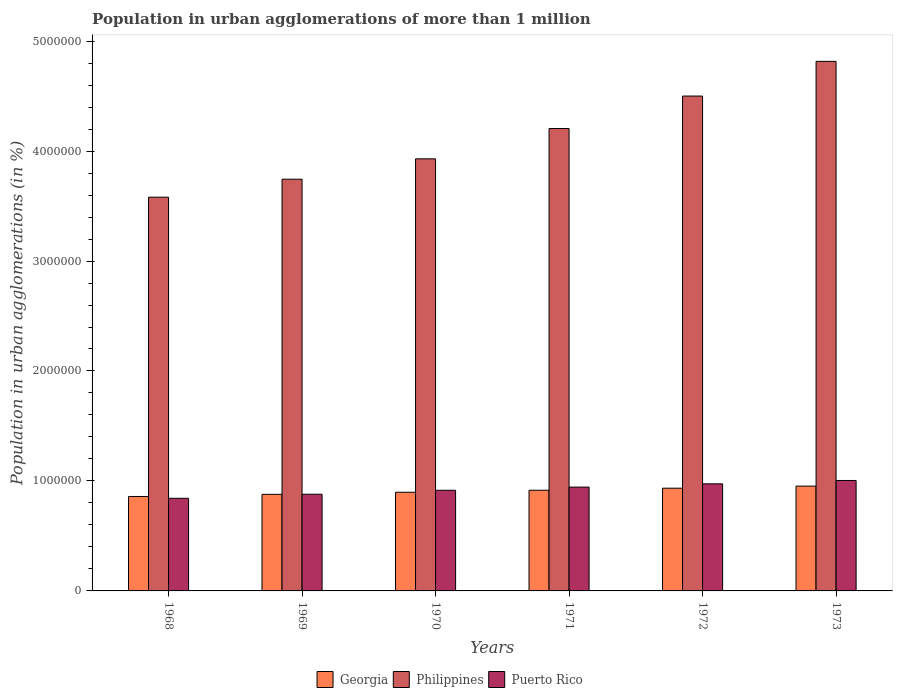How many different coloured bars are there?
Keep it short and to the point. 3. Are the number of bars per tick equal to the number of legend labels?
Give a very brief answer. Yes. How many bars are there on the 1st tick from the right?
Your answer should be compact. 3. What is the label of the 6th group of bars from the left?
Offer a very short reply. 1973. What is the population in urban agglomerations in Philippines in 1972?
Offer a terse response. 4.50e+06. Across all years, what is the maximum population in urban agglomerations in Philippines?
Make the answer very short. 4.82e+06. Across all years, what is the minimum population in urban agglomerations in Georgia?
Offer a very short reply. 8.59e+05. In which year was the population in urban agglomerations in Philippines maximum?
Offer a very short reply. 1973. In which year was the population in urban agglomerations in Georgia minimum?
Make the answer very short. 1968. What is the total population in urban agglomerations in Philippines in the graph?
Your response must be concise. 2.48e+07. What is the difference between the population in urban agglomerations in Puerto Rico in 1970 and that in 1971?
Your response must be concise. -2.88e+04. What is the difference between the population in urban agglomerations in Philippines in 1969 and the population in urban agglomerations in Puerto Rico in 1971?
Your answer should be compact. 2.80e+06. What is the average population in urban agglomerations in Puerto Rico per year?
Offer a very short reply. 9.27e+05. In the year 1969, what is the difference between the population in urban agglomerations in Georgia and population in urban agglomerations in Philippines?
Keep it short and to the point. -2.87e+06. In how many years, is the population in urban agglomerations in Philippines greater than 3200000 %?
Your answer should be compact. 6. What is the ratio of the population in urban agglomerations in Puerto Rico in 1970 to that in 1972?
Provide a succinct answer. 0.94. What is the difference between the highest and the second highest population in urban agglomerations in Georgia?
Provide a succinct answer. 1.90e+04. What is the difference between the highest and the lowest population in urban agglomerations in Georgia?
Provide a short and direct response. 9.44e+04. In how many years, is the population in urban agglomerations in Georgia greater than the average population in urban agglomerations in Georgia taken over all years?
Your response must be concise. 3. What does the 3rd bar from the right in 1973 represents?
Make the answer very short. Georgia. How many bars are there?
Make the answer very short. 18. How many years are there in the graph?
Offer a terse response. 6. Are the values on the major ticks of Y-axis written in scientific E-notation?
Your answer should be very brief. No. Does the graph contain any zero values?
Your answer should be compact. No. Does the graph contain grids?
Your answer should be compact. No. What is the title of the graph?
Your answer should be compact. Population in urban agglomerations of more than 1 million. Does "New Caledonia" appear as one of the legend labels in the graph?
Your response must be concise. No. What is the label or title of the X-axis?
Offer a very short reply. Years. What is the label or title of the Y-axis?
Provide a succinct answer. Population in urban agglomerations (in %). What is the Population in urban agglomerations (in %) of Georgia in 1968?
Your answer should be compact. 8.59e+05. What is the Population in urban agglomerations (in %) of Philippines in 1968?
Keep it short and to the point. 3.58e+06. What is the Population in urban agglomerations (in %) in Puerto Rico in 1968?
Keep it short and to the point. 8.42e+05. What is the Population in urban agglomerations (in %) in Georgia in 1969?
Offer a terse response. 8.78e+05. What is the Population in urban agglomerations (in %) of Philippines in 1969?
Provide a short and direct response. 3.74e+06. What is the Population in urban agglomerations (in %) in Puerto Rico in 1969?
Ensure brevity in your answer.  8.79e+05. What is the Population in urban agglomerations (in %) of Georgia in 1970?
Offer a very short reply. 8.97e+05. What is the Population in urban agglomerations (in %) in Philippines in 1970?
Ensure brevity in your answer.  3.93e+06. What is the Population in urban agglomerations (in %) of Puerto Rico in 1970?
Ensure brevity in your answer.  9.15e+05. What is the Population in urban agglomerations (in %) of Georgia in 1971?
Give a very brief answer. 9.16e+05. What is the Population in urban agglomerations (in %) of Philippines in 1971?
Give a very brief answer. 4.20e+06. What is the Population in urban agglomerations (in %) in Puerto Rico in 1971?
Your answer should be very brief. 9.44e+05. What is the Population in urban agglomerations (in %) of Georgia in 1972?
Your answer should be compact. 9.34e+05. What is the Population in urban agglomerations (in %) of Philippines in 1972?
Your answer should be compact. 4.50e+06. What is the Population in urban agglomerations (in %) of Puerto Rico in 1972?
Your answer should be very brief. 9.74e+05. What is the Population in urban agglomerations (in %) of Georgia in 1973?
Offer a terse response. 9.53e+05. What is the Population in urban agglomerations (in %) of Philippines in 1973?
Ensure brevity in your answer.  4.82e+06. What is the Population in urban agglomerations (in %) in Puerto Rico in 1973?
Provide a short and direct response. 1.00e+06. Across all years, what is the maximum Population in urban agglomerations (in %) of Georgia?
Ensure brevity in your answer.  9.53e+05. Across all years, what is the maximum Population in urban agglomerations (in %) in Philippines?
Your answer should be compact. 4.82e+06. Across all years, what is the maximum Population in urban agglomerations (in %) of Puerto Rico?
Provide a succinct answer. 1.00e+06. Across all years, what is the minimum Population in urban agglomerations (in %) in Georgia?
Offer a terse response. 8.59e+05. Across all years, what is the minimum Population in urban agglomerations (in %) of Philippines?
Offer a terse response. 3.58e+06. Across all years, what is the minimum Population in urban agglomerations (in %) in Puerto Rico?
Provide a succinct answer. 8.42e+05. What is the total Population in urban agglomerations (in %) of Georgia in the graph?
Offer a very short reply. 5.44e+06. What is the total Population in urban agglomerations (in %) in Philippines in the graph?
Make the answer very short. 2.48e+07. What is the total Population in urban agglomerations (in %) in Puerto Rico in the graph?
Your answer should be compact. 5.56e+06. What is the difference between the Population in urban agglomerations (in %) in Georgia in 1968 and that in 1969?
Make the answer very short. -1.94e+04. What is the difference between the Population in urban agglomerations (in %) of Philippines in 1968 and that in 1969?
Your answer should be very brief. -1.64e+05. What is the difference between the Population in urban agglomerations (in %) of Puerto Rico in 1968 and that in 1969?
Provide a succinct answer. -3.71e+04. What is the difference between the Population in urban agglomerations (in %) of Georgia in 1968 and that in 1970?
Your answer should be very brief. -3.84e+04. What is the difference between the Population in urban agglomerations (in %) of Philippines in 1968 and that in 1970?
Provide a short and direct response. -3.49e+05. What is the difference between the Population in urban agglomerations (in %) of Puerto Rico in 1968 and that in 1970?
Keep it short and to the point. -7.31e+04. What is the difference between the Population in urban agglomerations (in %) in Georgia in 1968 and that in 1971?
Offer a terse response. -5.67e+04. What is the difference between the Population in urban agglomerations (in %) of Philippines in 1968 and that in 1971?
Your answer should be very brief. -6.24e+05. What is the difference between the Population in urban agglomerations (in %) in Puerto Rico in 1968 and that in 1971?
Your answer should be very brief. -1.02e+05. What is the difference between the Population in urban agglomerations (in %) of Georgia in 1968 and that in 1972?
Provide a succinct answer. -7.54e+04. What is the difference between the Population in urban agglomerations (in %) in Philippines in 1968 and that in 1972?
Your response must be concise. -9.20e+05. What is the difference between the Population in urban agglomerations (in %) of Puerto Rico in 1968 and that in 1972?
Provide a short and direct response. -1.32e+05. What is the difference between the Population in urban agglomerations (in %) in Georgia in 1968 and that in 1973?
Provide a short and direct response. -9.44e+04. What is the difference between the Population in urban agglomerations (in %) in Philippines in 1968 and that in 1973?
Give a very brief answer. -1.24e+06. What is the difference between the Population in urban agglomerations (in %) in Puerto Rico in 1968 and that in 1973?
Your response must be concise. -1.62e+05. What is the difference between the Population in urban agglomerations (in %) in Georgia in 1969 and that in 1970?
Offer a very short reply. -1.90e+04. What is the difference between the Population in urban agglomerations (in %) of Philippines in 1969 and that in 1970?
Make the answer very short. -1.85e+05. What is the difference between the Population in urban agglomerations (in %) in Puerto Rico in 1969 and that in 1970?
Provide a succinct answer. -3.60e+04. What is the difference between the Population in urban agglomerations (in %) of Georgia in 1969 and that in 1971?
Your response must be concise. -3.73e+04. What is the difference between the Population in urban agglomerations (in %) of Philippines in 1969 and that in 1971?
Provide a short and direct response. -4.61e+05. What is the difference between the Population in urban agglomerations (in %) of Puerto Rico in 1969 and that in 1971?
Offer a very short reply. -6.48e+04. What is the difference between the Population in urban agglomerations (in %) in Georgia in 1969 and that in 1972?
Give a very brief answer. -5.60e+04. What is the difference between the Population in urban agglomerations (in %) in Philippines in 1969 and that in 1972?
Keep it short and to the point. -7.56e+05. What is the difference between the Population in urban agglomerations (in %) in Puerto Rico in 1969 and that in 1972?
Keep it short and to the point. -9.45e+04. What is the difference between the Population in urban agglomerations (in %) in Georgia in 1969 and that in 1973?
Give a very brief answer. -7.50e+04. What is the difference between the Population in urban agglomerations (in %) of Philippines in 1969 and that in 1973?
Keep it short and to the point. -1.07e+06. What is the difference between the Population in urban agglomerations (in %) of Puerto Rico in 1969 and that in 1973?
Provide a short and direct response. -1.25e+05. What is the difference between the Population in urban agglomerations (in %) of Georgia in 1970 and that in 1971?
Provide a succinct answer. -1.83e+04. What is the difference between the Population in urban agglomerations (in %) in Philippines in 1970 and that in 1971?
Your answer should be compact. -2.75e+05. What is the difference between the Population in urban agglomerations (in %) in Puerto Rico in 1970 and that in 1971?
Provide a short and direct response. -2.88e+04. What is the difference between the Population in urban agglomerations (in %) in Georgia in 1970 and that in 1972?
Keep it short and to the point. -3.70e+04. What is the difference between the Population in urban agglomerations (in %) in Philippines in 1970 and that in 1972?
Make the answer very short. -5.71e+05. What is the difference between the Population in urban agglomerations (in %) in Puerto Rico in 1970 and that in 1972?
Your answer should be compact. -5.85e+04. What is the difference between the Population in urban agglomerations (in %) of Georgia in 1970 and that in 1973?
Ensure brevity in your answer.  -5.60e+04. What is the difference between the Population in urban agglomerations (in %) of Philippines in 1970 and that in 1973?
Give a very brief answer. -8.86e+05. What is the difference between the Population in urban agglomerations (in %) in Puerto Rico in 1970 and that in 1973?
Keep it short and to the point. -8.91e+04. What is the difference between the Population in urban agglomerations (in %) of Georgia in 1971 and that in 1972?
Give a very brief answer. -1.87e+04. What is the difference between the Population in urban agglomerations (in %) in Philippines in 1971 and that in 1972?
Offer a very short reply. -2.95e+05. What is the difference between the Population in urban agglomerations (in %) of Puerto Rico in 1971 and that in 1972?
Offer a very short reply. -2.97e+04. What is the difference between the Population in urban agglomerations (in %) of Georgia in 1971 and that in 1973?
Provide a succinct answer. -3.77e+04. What is the difference between the Population in urban agglomerations (in %) in Philippines in 1971 and that in 1973?
Offer a very short reply. -6.11e+05. What is the difference between the Population in urban agglomerations (in %) of Puerto Rico in 1971 and that in 1973?
Provide a succinct answer. -6.03e+04. What is the difference between the Population in urban agglomerations (in %) in Georgia in 1972 and that in 1973?
Your answer should be very brief. -1.90e+04. What is the difference between the Population in urban agglomerations (in %) in Philippines in 1972 and that in 1973?
Give a very brief answer. -3.16e+05. What is the difference between the Population in urban agglomerations (in %) in Puerto Rico in 1972 and that in 1973?
Provide a succinct answer. -3.06e+04. What is the difference between the Population in urban agglomerations (in %) in Georgia in 1968 and the Population in urban agglomerations (in %) in Philippines in 1969?
Make the answer very short. -2.89e+06. What is the difference between the Population in urban agglomerations (in %) in Georgia in 1968 and the Population in urban agglomerations (in %) in Puerto Rico in 1969?
Offer a terse response. -2.05e+04. What is the difference between the Population in urban agglomerations (in %) in Philippines in 1968 and the Population in urban agglomerations (in %) in Puerto Rico in 1969?
Ensure brevity in your answer.  2.70e+06. What is the difference between the Population in urban agglomerations (in %) in Georgia in 1968 and the Population in urban agglomerations (in %) in Philippines in 1970?
Provide a succinct answer. -3.07e+06. What is the difference between the Population in urban agglomerations (in %) of Georgia in 1968 and the Population in urban agglomerations (in %) of Puerto Rico in 1970?
Offer a terse response. -5.65e+04. What is the difference between the Population in urban agglomerations (in %) in Philippines in 1968 and the Population in urban agglomerations (in %) in Puerto Rico in 1970?
Your answer should be compact. 2.67e+06. What is the difference between the Population in urban agglomerations (in %) of Georgia in 1968 and the Population in urban agglomerations (in %) of Philippines in 1971?
Give a very brief answer. -3.35e+06. What is the difference between the Population in urban agglomerations (in %) of Georgia in 1968 and the Population in urban agglomerations (in %) of Puerto Rico in 1971?
Offer a very short reply. -8.53e+04. What is the difference between the Population in urban agglomerations (in %) in Philippines in 1968 and the Population in urban agglomerations (in %) in Puerto Rico in 1971?
Your answer should be very brief. 2.64e+06. What is the difference between the Population in urban agglomerations (in %) in Georgia in 1968 and the Population in urban agglomerations (in %) in Philippines in 1972?
Offer a very short reply. -3.64e+06. What is the difference between the Population in urban agglomerations (in %) in Georgia in 1968 and the Population in urban agglomerations (in %) in Puerto Rico in 1972?
Your response must be concise. -1.15e+05. What is the difference between the Population in urban agglomerations (in %) in Philippines in 1968 and the Population in urban agglomerations (in %) in Puerto Rico in 1972?
Offer a very short reply. 2.61e+06. What is the difference between the Population in urban agglomerations (in %) of Georgia in 1968 and the Population in urban agglomerations (in %) of Philippines in 1973?
Your answer should be very brief. -3.96e+06. What is the difference between the Population in urban agglomerations (in %) of Georgia in 1968 and the Population in urban agglomerations (in %) of Puerto Rico in 1973?
Make the answer very short. -1.46e+05. What is the difference between the Population in urban agglomerations (in %) of Philippines in 1968 and the Population in urban agglomerations (in %) of Puerto Rico in 1973?
Offer a terse response. 2.58e+06. What is the difference between the Population in urban agglomerations (in %) of Georgia in 1969 and the Population in urban agglomerations (in %) of Philippines in 1970?
Provide a succinct answer. -3.05e+06. What is the difference between the Population in urban agglomerations (in %) in Georgia in 1969 and the Population in urban agglomerations (in %) in Puerto Rico in 1970?
Make the answer very short. -3.71e+04. What is the difference between the Population in urban agglomerations (in %) of Philippines in 1969 and the Population in urban agglomerations (in %) of Puerto Rico in 1970?
Provide a succinct answer. 2.83e+06. What is the difference between the Population in urban agglomerations (in %) of Georgia in 1969 and the Population in urban agglomerations (in %) of Philippines in 1971?
Offer a terse response. -3.33e+06. What is the difference between the Population in urban agglomerations (in %) in Georgia in 1969 and the Population in urban agglomerations (in %) in Puerto Rico in 1971?
Your answer should be compact. -6.58e+04. What is the difference between the Population in urban agglomerations (in %) in Philippines in 1969 and the Population in urban agglomerations (in %) in Puerto Rico in 1971?
Offer a terse response. 2.80e+06. What is the difference between the Population in urban agglomerations (in %) in Georgia in 1969 and the Population in urban agglomerations (in %) in Philippines in 1972?
Give a very brief answer. -3.62e+06. What is the difference between the Population in urban agglomerations (in %) in Georgia in 1969 and the Population in urban agglomerations (in %) in Puerto Rico in 1972?
Keep it short and to the point. -9.56e+04. What is the difference between the Population in urban agglomerations (in %) of Philippines in 1969 and the Population in urban agglomerations (in %) of Puerto Rico in 1972?
Give a very brief answer. 2.77e+06. What is the difference between the Population in urban agglomerations (in %) of Georgia in 1969 and the Population in urban agglomerations (in %) of Philippines in 1973?
Provide a succinct answer. -3.94e+06. What is the difference between the Population in urban agglomerations (in %) in Georgia in 1969 and the Population in urban agglomerations (in %) in Puerto Rico in 1973?
Offer a very short reply. -1.26e+05. What is the difference between the Population in urban agglomerations (in %) in Philippines in 1969 and the Population in urban agglomerations (in %) in Puerto Rico in 1973?
Give a very brief answer. 2.74e+06. What is the difference between the Population in urban agglomerations (in %) in Georgia in 1970 and the Population in urban agglomerations (in %) in Philippines in 1971?
Offer a very short reply. -3.31e+06. What is the difference between the Population in urban agglomerations (in %) in Georgia in 1970 and the Population in urban agglomerations (in %) in Puerto Rico in 1971?
Keep it short and to the point. -4.68e+04. What is the difference between the Population in urban agglomerations (in %) of Philippines in 1970 and the Population in urban agglomerations (in %) of Puerto Rico in 1971?
Your answer should be compact. 2.99e+06. What is the difference between the Population in urban agglomerations (in %) of Georgia in 1970 and the Population in urban agglomerations (in %) of Philippines in 1972?
Your answer should be very brief. -3.60e+06. What is the difference between the Population in urban agglomerations (in %) of Georgia in 1970 and the Population in urban agglomerations (in %) of Puerto Rico in 1972?
Your answer should be compact. -7.66e+04. What is the difference between the Population in urban agglomerations (in %) in Philippines in 1970 and the Population in urban agglomerations (in %) in Puerto Rico in 1972?
Your response must be concise. 2.96e+06. What is the difference between the Population in urban agglomerations (in %) in Georgia in 1970 and the Population in urban agglomerations (in %) in Philippines in 1973?
Ensure brevity in your answer.  -3.92e+06. What is the difference between the Population in urban agglomerations (in %) in Georgia in 1970 and the Population in urban agglomerations (in %) in Puerto Rico in 1973?
Your answer should be compact. -1.07e+05. What is the difference between the Population in urban agglomerations (in %) of Philippines in 1970 and the Population in urban agglomerations (in %) of Puerto Rico in 1973?
Provide a short and direct response. 2.92e+06. What is the difference between the Population in urban agglomerations (in %) in Georgia in 1971 and the Population in urban agglomerations (in %) in Philippines in 1972?
Your answer should be very brief. -3.58e+06. What is the difference between the Population in urban agglomerations (in %) of Georgia in 1971 and the Population in urban agglomerations (in %) of Puerto Rico in 1972?
Give a very brief answer. -5.83e+04. What is the difference between the Population in urban agglomerations (in %) in Philippines in 1971 and the Population in urban agglomerations (in %) in Puerto Rico in 1972?
Keep it short and to the point. 3.23e+06. What is the difference between the Population in urban agglomerations (in %) in Georgia in 1971 and the Population in urban agglomerations (in %) in Philippines in 1973?
Your response must be concise. -3.90e+06. What is the difference between the Population in urban agglomerations (in %) of Georgia in 1971 and the Population in urban agglomerations (in %) of Puerto Rico in 1973?
Make the answer very short. -8.89e+04. What is the difference between the Population in urban agglomerations (in %) in Philippines in 1971 and the Population in urban agglomerations (in %) in Puerto Rico in 1973?
Provide a short and direct response. 3.20e+06. What is the difference between the Population in urban agglomerations (in %) in Georgia in 1972 and the Population in urban agglomerations (in %) in Philippines in 1973?
Give a very brief answer. -3.88e+06. What is the difference between the Population in urban agglomerations (in %) in Georgia in 1972 and the Population in urban agglomerations (in %) in Puerto Rico in 1973?
Your answer should be compact. -7.02e+04. What is the difference between the Population in urban agglomerations (in %) in Philippines in 1972 and the Population in urban agglomerations (in %) in Puerto Rico in 1973?
Provide a succinct answer. 3.50e+06. What is the average Population in urban agglomerations (in %) in Georgia per year?
Offer a very short reply. 9.06e+05. What is the average Population in urban agglomerations (in %) in Philippines per year?
Provide a short and direct response. 4.13e+06. What is the average Population in urban agglomerations (in %) of Puerto Rico per year?
Keep it short and to the point. 9.27e+05. In the year 1968, what is the difference between the Population in urban agglomerations (in %) in Georgia and Population in urban agglomerations (in %) in Philippines?
Provide a short and direct response. -2.72e+06. In the year 1968, what is the difference between the Population in urban agglomerations (in %) of Georgia and Population in urban agglomerations (in %) of Puerto Rico?
Provide a short and direct response. 1.66e+04. In the year 1968, what is the difference between the Population in urban agglomerations (in %) of Philippines and Population in urban agglomerations (in %) of Puerto Rico?
Offer a very short reply. 2.74e+06. In the year 1969, what is the difference between the Population in urban agglomerations (in %) in Georgia and Population in urban agglomerations (in %) in Philippines?
Ensure brevity in your answer.  -2.87e+06. In the year 1969, what is the difference between the Population in urban agglomerations (in %) in Georgia and Population in urban agglomerations (in %) in Puerto Rico?
Give a very brief answer. -1052. In the year 1969, what is the difference between the Population in urban agglomerations (in %) in Philippines and Population in urban agglomerations (in %) in Puerto Rico?
Your answer should be compact. 2.86e+06. In the year 1970, what is the difference between the Population in urban agglomerations (in %) in Georgia and Population in urban agglomerations (in %) in Philippines?
Give a very brief answer. -3.03e+06. In the year 1970, what is the difference between the Population in urban agglomerations (in %) of Georgia and Population in urban agglomerations (in %) of Puerto Rico?
Offer a terse response. -1.81e+04. In the year 1970, what is the difference between the Population in urban agglomerations (in %) of Philippines and Population in urban agglomerations (in %) of Puerto Rico?
Make the answer very short. 3.01e+06. In the year 1971, what is the difference between the Population in urban agglomerations (in %) of Georgia and Population in urban agglomerations (in %) of Philippines?
Your response must be concise. -3.29e+06. In the year 1971, what is the difference between the Population in urban agglomerations (in %) of Georgia and Population in urban agglomerations (in %) of Puerto Rico?
Your response must be concise. -2.86e+04. In the year 1971, what is the difference between the Population in urban agglomerations (in %) in Philippines and Population in urban agglomerations (in %) in Puerto Rico?
Offer a terse response. 3.26e+06. In the year 1972, what is the difference between the Population in urban agglomerations (in %) of Georgia and Population in urban agglomerations (in %) of Philippines?
Give a very brief answer. -3.57e+06. In the year 1972, what is the difference between the Population in urban agglomerations (in %) in Georgia and Population in urban agglomerations (in %) in Puerto Rico?
Make the answer very short. -3.96e+04. In the year 1972, what is the difference between the Population in urban agglomerations (in %) in Philippines and Population in urban agglomerations (in %) in Puerto Rico?
Offer a very short reply. 3.53e+06. In the year 1973, what is the difference between the Population in urban agglomerations (in %) in Georgia and Population in urban agglomerations (in %) in Philippines?
Give a very brief answer. -3.86e+06. In the year 1973, what is the difference between the Population in urban agglomerations (in %) of Georgia and Population in urban agglomerations (in %) of Puerto Rico?
Your response must be concise. -5.12e+04. In the year 1973, what is the difference between the Population in urban agglomerations (in %) in Philippines and Population in urban agglomerations (in %) in Puerto Rico?
Offer a terse response. 3.81e+06. What is the ratio of the Population in urban agglomerations (in %) of Georgia in 1968 to that in 1969?
Offer a terse response. 0.98. What is the ratio of the Population in urban agglomerations (in %) in Philippines in 1968 to that in 1969?
Your response must be concise. 0.96. What is the ratio of the Population in urban agglomerations (in %) of Puerto Rico in 1968 to that in 1969?
Your answer should be compact. 0.96. What is the ratio of the Population in urban agglomerations (in %) in Georgia in 1968 to that in 1970?
Offer a very short reply. 0.96. What is the ratio of the Population in urban agglomerations (in %) in Philippines in 1968 to that in 1970?
Offer a terse response. 0.91. What is the ratio of the Population in urban agglomerations (in %) in Puerto Rico in 1968 to that in 1970?
Your answer should be compact. 0.92. What is the ratio of the Population in urban agglomerations (in %) of Georgia in 1968 to that in 1971?
Provide a short and direct response. 0.94. What is the ratio of the Population in urban agglomerations (in %) in Philippines in 1968 to that in 1971?
Your answer should be compact. 0.85. What is the ratio of the Population in urban agglomerations (in %) of Puerto Rico in 1968 to that in 1971?
Ensure brevity in your answer.  0.89. What is the ratio of the Population in urban agglomerations (in %) in Georgia in 1968 to that in 1972?
Offer a terse response. 0.92. What is the ratio of the Population in urban agglomerations (in %) in Philippines in 1968 to that in 1972?
Ensure brevity in your answer.  0.8. What is the ratio of the Population in urban agglomerations (in %) of Puerto Rico in 1968 to that in 1972?
Keep it short and to the point. 0.86. What is the ratio of the Population in urban agglomerations (in %) of Georgia in 1968 to that in 1973?
Your answer should be very brief. 0.9. What is the ratio of the Population in urban agglomerations (in %) in Philippines in 1968 to that in 1973?
Ensure brevity in your answer.  0.74. What is the ratio of the Population in urban agglomerations (in %) of Puerto Rico in 1968 to that in 1973?
Offer a very short reply. 0.84. What is the ratio of the Population in urban agglomerations (in %) in Georgia in 1969 to that in 1970?
Provide a succinct answer. 0.98. What is the ratio of the Population in urban agglomerations (in %) of Philippines in 1969 to that in 1970?
Offer a terse response. 0.95. What is the ratio of the Population in urban agglomerations (in %) of Puerto Rico in 1969 to that in 1970?
Your answer should be compact. 0.96. What is the ratio of the Population in urban agglomerations (in %) of Georgia in 1969 to that in 1971?
Your response must be concise. 0.96. What is the ratio of the Population in urban agglomerations (in %) in Philippines in 1969 to that in 1971?
Keep it short and to the point. 0.89. What is the ratio of the Population in urban agglomerations (in %) of Puerto Rico in 1969 to that in 1971?
Provide a succinct answer. 0.93. What is the ratio of the Population in urban agglomerations (in %) in Georgia in 1969 to that in 1972?
Your answer should be very brief. 0.94. What is the ratio of the Population in urban agglomerations (in %) of Philippines in 1969 to that in 1972?
Provide a short and direct response. 0.83. What is the ratio of the Population in urban agglomerations (in %) of Puerto Rico in 1969 to that in 1972?
Offer a very short reply. 0.9. What is the ratio of the Population in urban agglomerations (in %) of Georgia in 1969 to that in 1973?
Make the answer very short. 0.92. What is the ratio of the Population in urban agglomerations (in %) of Philippines in 1969 to that in 1973?
Provide a short and direct response. 0.78. What is the ratio of the Population in urban agglomerations (in %) of Puerto Rico in 1969 to that in 1973?
Make the answer very short. 0.88. What is the ratio of the Population in urban agglomerations (in %) in Philippines in 1970 to that in 1971?
Offer a terse response. 0.93. What is the ratio of the Population in urban agglomerations (in %) of Puerto Rico in 1970 to that in 1971?
Make the answer very short. 0.97. What is the ratio of the Population in urban agglomerations (in %) in Georgia in 1970 to that in 1972?
Provide a succinct answer. 0.96. What is the ratio of the Population in urban agglomerations (in %) in Philippines in 1970 to that in 1972?
Make the answer very short. 0.87. What is the ratio of the Population in urban agglomerations (in %) of Puerto Rico in 1970 to that in 1972?
Offer a terse response. 0.94. What is the ratio of the Population in urban agglomerations (in %) of Georgia in 1970 to that in 1973?
Provide a short and direct response. 0.94. What is the ratio of the Population in urban agglomerations (in %) in Philippines in 1970 to that in 1973?
Give a very brief answer. 0.82. What is the ratio of the Population in urban agglomerations (in %) of Puerto Rico in 1970 to that in 1973?
Offer a terse response. 0.91. What is the ratio of the Population in urban agglomerations (in %) of Philippines in 1971 to that in 1972?
Provide a succinct answer. 0.93. What is the ratio of the Population in urban agglomerations (in %) in Puerto Rico in 1971 to that in 1972?
Give a very brief answer. 0.97. What is the ratio of the Population in urban agglomerations (in %) of Georgia in 1971 to that in 1973?
Offer a terse response. 0.96. What is the ratio of the Population in urban agglomerations (in %) of Philippines in 1971 to that in 1973?
Give a very brief answer. 0.87. What is the ratio of the Population in urban agglomerations (in %) of Puerto Rico in 1971 to that in 1973?
Make the answer very short. 0.94. What is the ratio of the Population in urban agglomerations (in %) of Georgia in 1972 to that in 1973?
Keep it short and to the point. 0.98. What is the ratio of the Population in urban agglomerations (in %) of Philippines in 1972 to that in 1973?
Give a very brief answer. 0.93. What is the ratio of the Population in urban agglomerations (in %) of Puerto Rico in 1972 to that in 1973?
Offer a very short reply. 0.97. What is the difference between the highest and the second highest Population in urban agglomerations (in %) in Georgia?
Offer a very short reply. 1.90e+04. What is the difference between the highest and the second highest Population in urban agglomerations (in %) of Philippines?
Provide a short and direct response. 3.16e+05. What is the difference between the highest and the second highest Population in urban agglomerations (in %) of Puerto Rico?
Your response must be concise. 3.06e+04. What is the difference between the highest and the lowest Population in urban agglomerations (in %) of Georgia?
Provide a succinct answer. 9.44e+04. What is the difference between the highest and the lowest Population in urban agglomerations (in %) in Philippines?
Offer a terse response. 1.24e+06. What is the difference between the highest and the lowest Population in urban agglomerations (in %) in Puerto Rico?
Provide a succinct answer. 1.62e+05. 